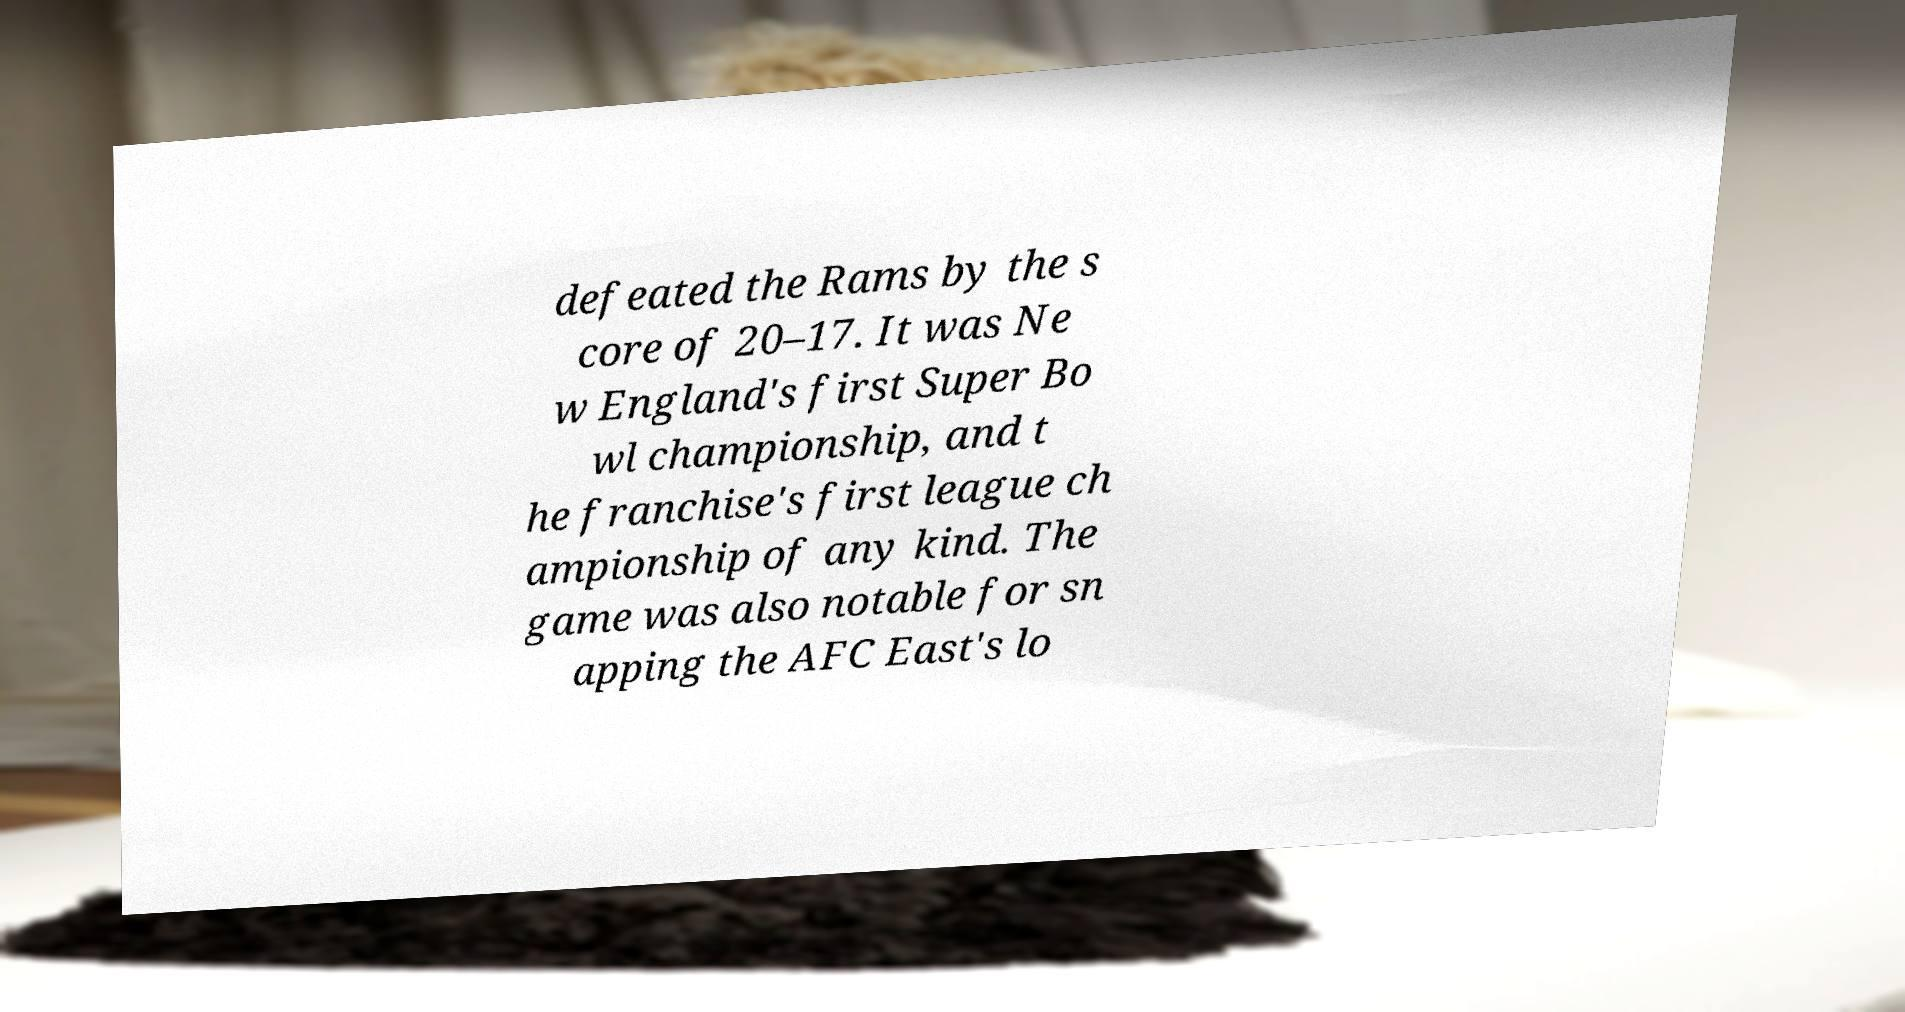What messages or text are displayed in this image? I need them in a readable, typed format. defeated the Rams by the s core of 20–17. It was Ne w England's first Super Bo wl championship, and t he franchise's first league ch ampionship of any kind. The game was also notable for sn apping the AFC East's lo 